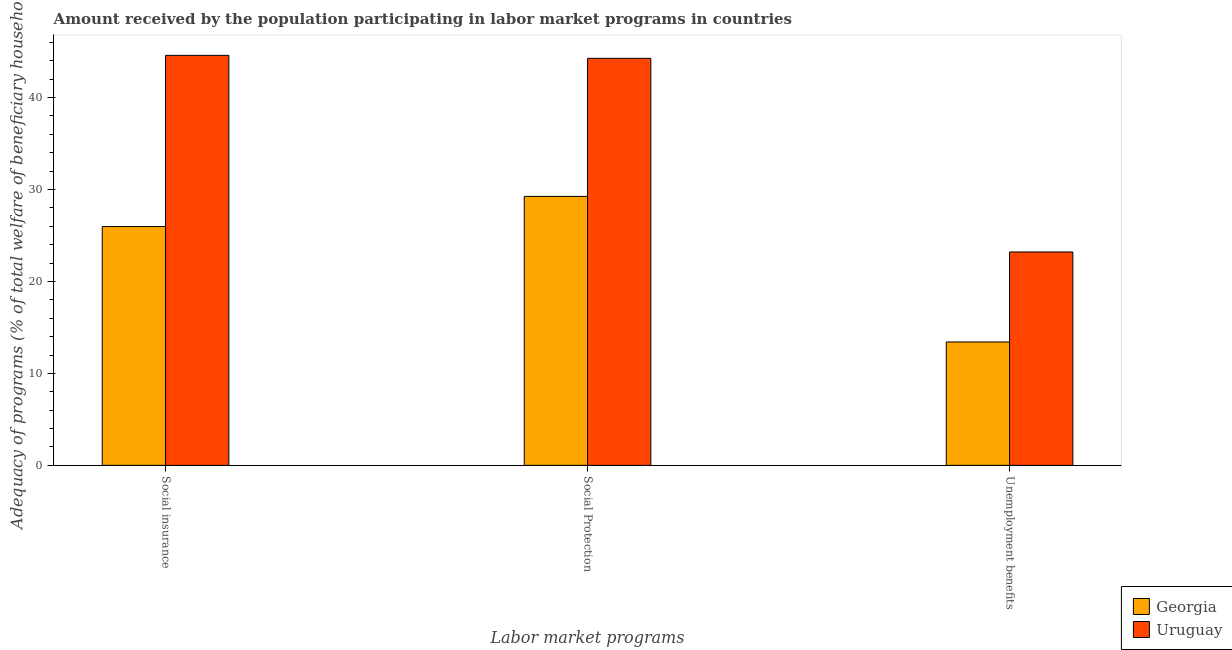How many different coloured bars are there?
Your answer should be compact. 2. How many groups of bars are there?
Your answer should be very brief. 3. Are the number of bars on each tick of the X-axis equal?
Offer a very short reply. Yes. How many bars are there on the 3rd tick from the left?
Keep it short and to the point. 2. What is the label of the 1st group of bars from the left?
Your answer should be very brief. Social insurance. What is the amount received by the population participating in social protection programs in Georgia?
Ensure brevity in your answer.  29.25. Across all countries, what is the maximum amount received by the population participating in unemployment benefits programs?
Your response must be concise. 23.2. Across all countries, what is the minimum amount received by the population participating in unemployment benefits programs?
Offer a terse response. 13.42. In which country was the amount received by the population participating in social protection programs maximum?
Provide a succinct answer. Uruguay. In which country was the amount received by the population participating in social insurance programs minimum?
Your answer should be compact. Georgia. What is the total amount received by the population participating in unemployment benefits programs in the graph?
Your answer should be compact. 36.62. What is the difference between the amount received by the population participating in social protection programs in Georgia and that in Uruguay?
Provide a short and direct response. -15.02. What is the difference between the amount received by the population participating in social protection programs in Uruguay and the amount received by the population participating in social insurance programs in Georgia?
Your answer should be compact. 18.29. What is the average amount received by the population participating in social protection programs per country?
Provide a succinct answer. 36.76. What is the difference between the amount received by the population participating in social insurance programs and amount received by the population participating in unemployment benefits programs in Uruguay?
Offer a terse response. 21.38. In how many countries, is the amount received by the population participating in social insurance programs greater than 36 %?
Make the answer very short. 1. What is the ratio of the amount received by the population participating in social insurance programs in Georgia to that in Uruguay?
Ensure brevity in your answer.  0.58. Is the amount received by the population participating in social insurance programs in Uruguay less than that in Georgia?
Make the answer very short. No. Is the difference between the amount received by the population participating in social insurance programs in Georgia and Uruguay greater than the difference between the amount received by the population participating in social protection programs in Georgia and Uruguay?
Make the answer very short. No. What is the difference between the highest and the second highest amount received by the population participating in social protection programs?
Offer a very short reply. 15.02. What is the difference between the highest and the lowest amount received by the population participating in social protection programs?
Provide a succinct answer. 15.02. Is the sum of the amount received by the population participating in social insurance programs in Georgia and Uruguay greater than the maximum amount received by the population participating in social protection programs across all countries?
Your answer should be very brief. Yes. What does the 2nd bar from the left in Social Protection represents?
Provide a succinct answer. Uruguay. What does the 2nd bar from the right in Social Protection represents?
Give a very brief answer. Georgia. What is the difference between two consecutive major ticks on the Y-axis?
Offer a terse response. 10. Does the graph contain any zero values?
Offer a terse response. No. Does the graph contain grids?
Give a very brief answer. No. How many legend labels are there?
Make the answer very short. 2. What is the title of the graph?
Provide a succinct answer. Amount received by the population participating in labor market programs in countries. What is the label or title of the X-axis?
Make the answer very short. Labor market programs. What is the label or title of the Y-axis?
Your response must be concise. Adequacy of programs (% of total welfare of beneficiary households). What is the Adequacy of programs (% of total welfare of beneficiary households) of Georgia in Social insurance?
Your answer should be very brief. 25.97. What is the Adequacy of programs (% of total welfare of beneficiary households) of Uruguay in Social insurance?
Keep it short and to the point. 44.58. What is the Adequacy of programs (% of total welfare of beneficiary households) in Georgia in Social Protection?
Your answer should be very brief. 29.25. What is the Adequacy of programs (% of total welfare of beneficiary households) of Uruguay in Social Protection?
Offer a terse response. 44.26. What is the Adequacy of programs (% of total welfare of beneficiary households) of Georgia in Unemployment benefits?
Provide a short and direct response. 13.42. What is the Adequacy of programs (% of total welfare of beneficiary households) of Uruguay in Unemployment benefits?
Provide a succinct answer. 23.2. Across all Labor market programs, what is the maximum Adequacy of programs (% of total welfare of beneficiary households) of Georgia?
Offer a very short reply. 29.25. Across all Labor market programs, what is the maximum Adequacy of programs (% of total welfare of beneficiary households) in Uruguay?
Give a very brief answer. 44.58. Across all Labor market programs, what is the minimum Adequacy of programs (% of total welfare of beneficiary households) in Georgia?
Your answer should be very brief. 13.42. Across all Labor market programs, what is the minimum Adequacy of programs (% of total welfare of beneficiary households) in Uruguay?
Provide a short and direct response. 23.2. What is the total Adequacy of programs (% of total welfare of beneficiary households) of Georgia in the graph?
Provide a short and direct response. 68.63. What is the total Adequacy of programs (% of total welfare of beneficiary households) of Uruguay in the graph?
Keep it short and to the point. 112.05. What is the difference between the Adequacy of programs (% of total welfare of beneficiary households) of Georgia in Social insurance and that in Social Protection?
Your answer should be compact. -3.28. What is the difference between the Adequacy of programs (% of total welfare of beneficiary households) of Uruguay in Social insurance and that in Social Protection?
Your answer should be compact. 0.32. What is the difference between the Adequacy of programs (% of total welfare of beneficiary households) in Georgia in Social insurance and that in Unemployment benefits?
Provide a succinct answer. 12.55. What is the difference between the Adequacy of programs (% of total welfare of beneficiary households) in Uruguay in Social insurance and that in Unemployment benefits?
Offer a very short reply. 21.38. What is the difference between the Adequacy of programs (% of total welfare of beneficiary households) of Georgia in Social Protection and that in Unemployment benefits?
Ensure brevity in your answer.  15.83. What is the difference between the Adequacy of programs (% of total welfare of beneficiary households) of Uruguay in Social Protection and that in Unemployment benefits?
Provide a short and direct response. 21.06. What is the difference between the Adequacy of programs (% of total welfare of beneficiary households) in Georgia in Social insurance and the Adequacy of programs (% of total welfare of beneficiary households) in Uruguay in Social Protection?
Ensure brevity in your answer.  -18.29. What is the difference between the Adequacy of programs (% of total welfare of beneficiary households) of Georgia in Social insurance and the Adequacy of programs (% of total welfare of beneficiary households) of Uruguay in Unemployment benefits?
Ensure brevity in your answer.  2.77. What is the difference between the Adequacy of programs (% of total welfare of beneficiary households) of Georgia in Social Protection and the Adequacy of programs (% of total welfare of beneficiary households) of Uruguay in Unemployment benefits?
Ensure brevity in your answer.  6.04. What is the average Adequacy of programs (% of total welfare of beneficiary households) in Georgia per Labor market programs?
Give a very brief answer. 22.88. What is the average Adequacy of programs (% of total welfare of beneficiary households) of Uruguay per Labor market programs?
Give a very brief answer. 37.35. What is the difference between the Adequacy of programs (% of total welfare of beneficiary households) of Georgia and Adequacy of programs (% of total welfare of beneficiary households) of Uruguay in Social insurance?
Provide a short and direct response. -18.61. What is the difference between the Adequacy of programs (% of total welfare of beneficiary households) of Georgia and Adequacy of programs (% of total welfare of beneficiary households) of Uruguay in Social Protection?
Your answer should be very brief. -15.02. What is the difference between the Adequacy of programs (% of total welfare of beneficiary households) in Georgia and Adequacy of programs (% of total welfare of beneficiary households) in Uruguay in Unemployment benefits?
Your answer should be very brief. -9.79. What is the ratio of the Adequacy of programs (% of total welfare of beneficiary households) of Georgia in Social insurance to that in Social Protection?
Provide a succinct answer. 0.89. What is the ratio of the Adequacy of programs (% of total welfare of beneficiary households) of Georgia in Social insurance to that in Unemployment benefits?
Offer a terse response. 1.94. What is the ratio of the Adequacy of programs (% of total welfare of beneficiary households) of Uruguay in Social insurance to that in Unemployment benefits?
Offer a very short reply. 1.92. What is the ratio of the Adequacy of programs (% of total welfare of beneficiary households) of Georgia in Social Protection to that in Unemployment benefits?
Make the answer very short. 2.18. What is the ratio of the Adequacy of programs (% of total welfare of beneficiary households) of Uruguay in Social Protection to that in Unemployment benefits?
Give a very brief answer. 1.91. What is the difference between the highest and the second highest Adequacy of programs (% of total welfare of beneficiary households) of Georgia?
Your response must be concise. 3.28. What is the difference between the highest and the second highest Adequacy of programs (% of total welfare of beneficiary households) of Uruguay?
Offer a terse response. 0.32. What is the difference between the highest and the lowest Adequacy of programs (% of total welfare of beneficiary households) in Georgia?
Your answer should be compact. 15.83. What is the difference between the highest and the lowest Adequacy of programs (% of total welfare of beneficiary households) in Uruguay?
Give a very brief answer. 21.38. 